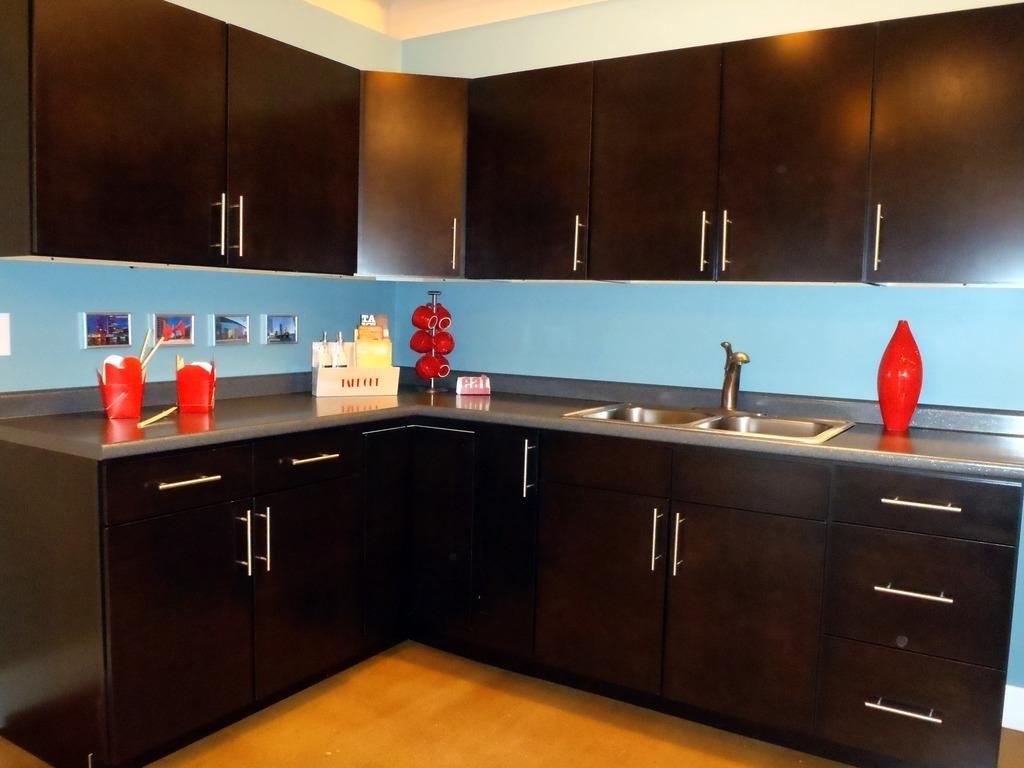Describe this image in one or two sentences. In this image, we can see a kitchen. There is a countertop contains cups and sink. There are cupboards in the middle of the image. 